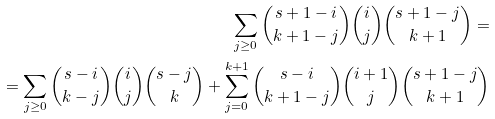Convert formula to latex. <formula><loc_0><loc_0><loc_500><loc_500>\sum _ { j \geq 0 } \binom { s + 1 - i } { k + 1 - j } \binom { i } { j } \binom { s + 1 - j } { k + 1 } = \\ = \sum _ { j \geq 0 } \binom { s - i } { k - j } \binom { i } { j } \binom { s - j } { k } + \sum _ { j = 0 } ^ { k + 1 } \binom { s - i } { k + 1 - j } \binom { i + 1 } { j } \binom { s + 1 - j } { k + 1 }</formula> 